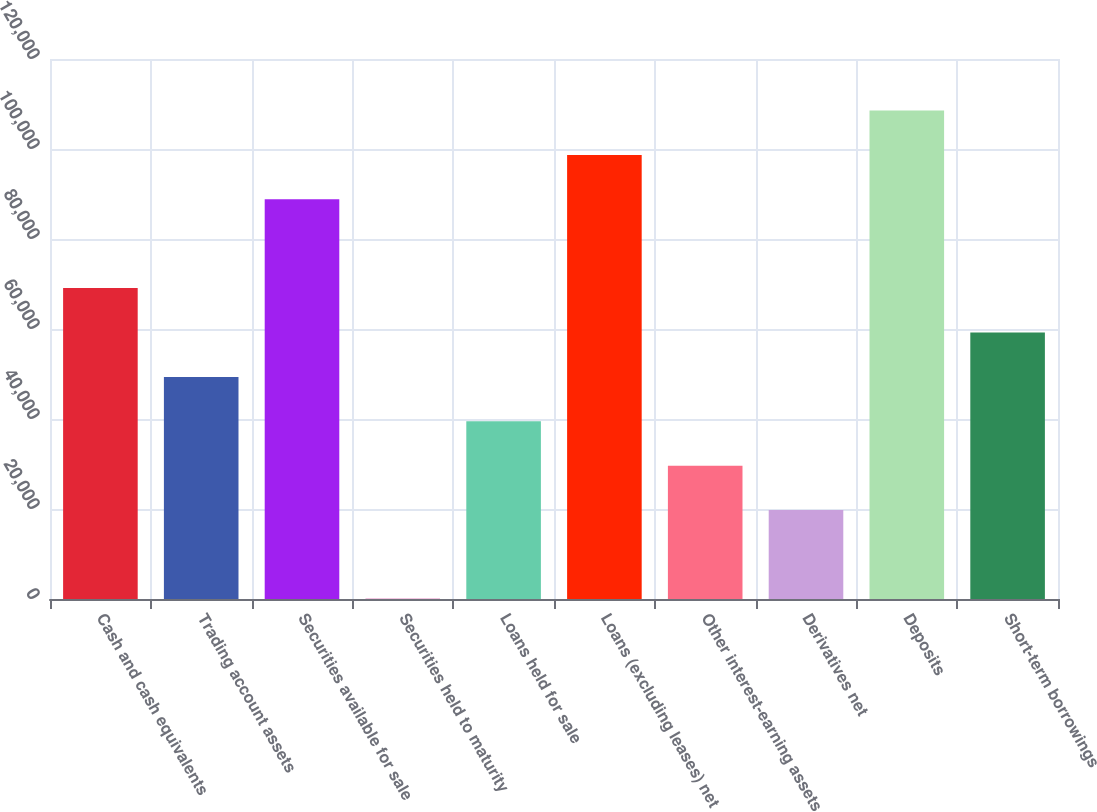<chart> <loc_0><loc_0><loc_500><loc_500><bar_chart><fcel>Cash and cash equivalents<fcel>Trading account assets<fcel>Securities available for sale<fcel>Securities held to maturity<fcel>Loans held for sale<fcel>Loans (excluding leases) net<fcel>Other interest-earning assets<fcel>Derivatives net<fcel>Deposits<fcel>Short-term borrowings<nl><fcel>69085.3<fcel>49355.5<fcel>88815.1<fcel>31<fcel>39490.6<fcel>98680<fcel>29625.7<fcel>19760.8<fcel>108545<fcel>59220.4<nl></chart> 